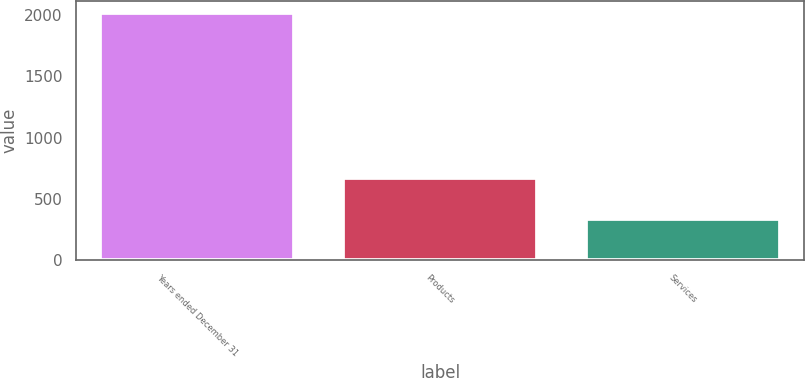<chart> <loc_0><loc_0><loc_500><loc_500><bar_chart><fcel>Years ended December 31<fcel>Products<fcel>Services<nl><fcel>2014<fcel>667<fcel>339<nl></chart> 